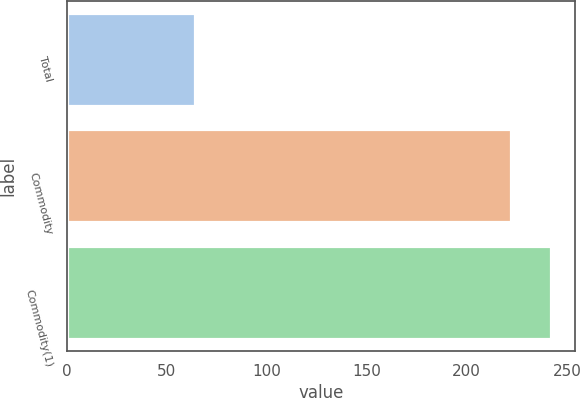Convert chart to OTSL. <chart><loc_0><loc_0><loc_500><loc_500><bar_chart><fcel>Total<fcel>Commodity<fcel>Commodity(1)<nl><fcel>64<fcel>222<fcel>242<nl></chart> 